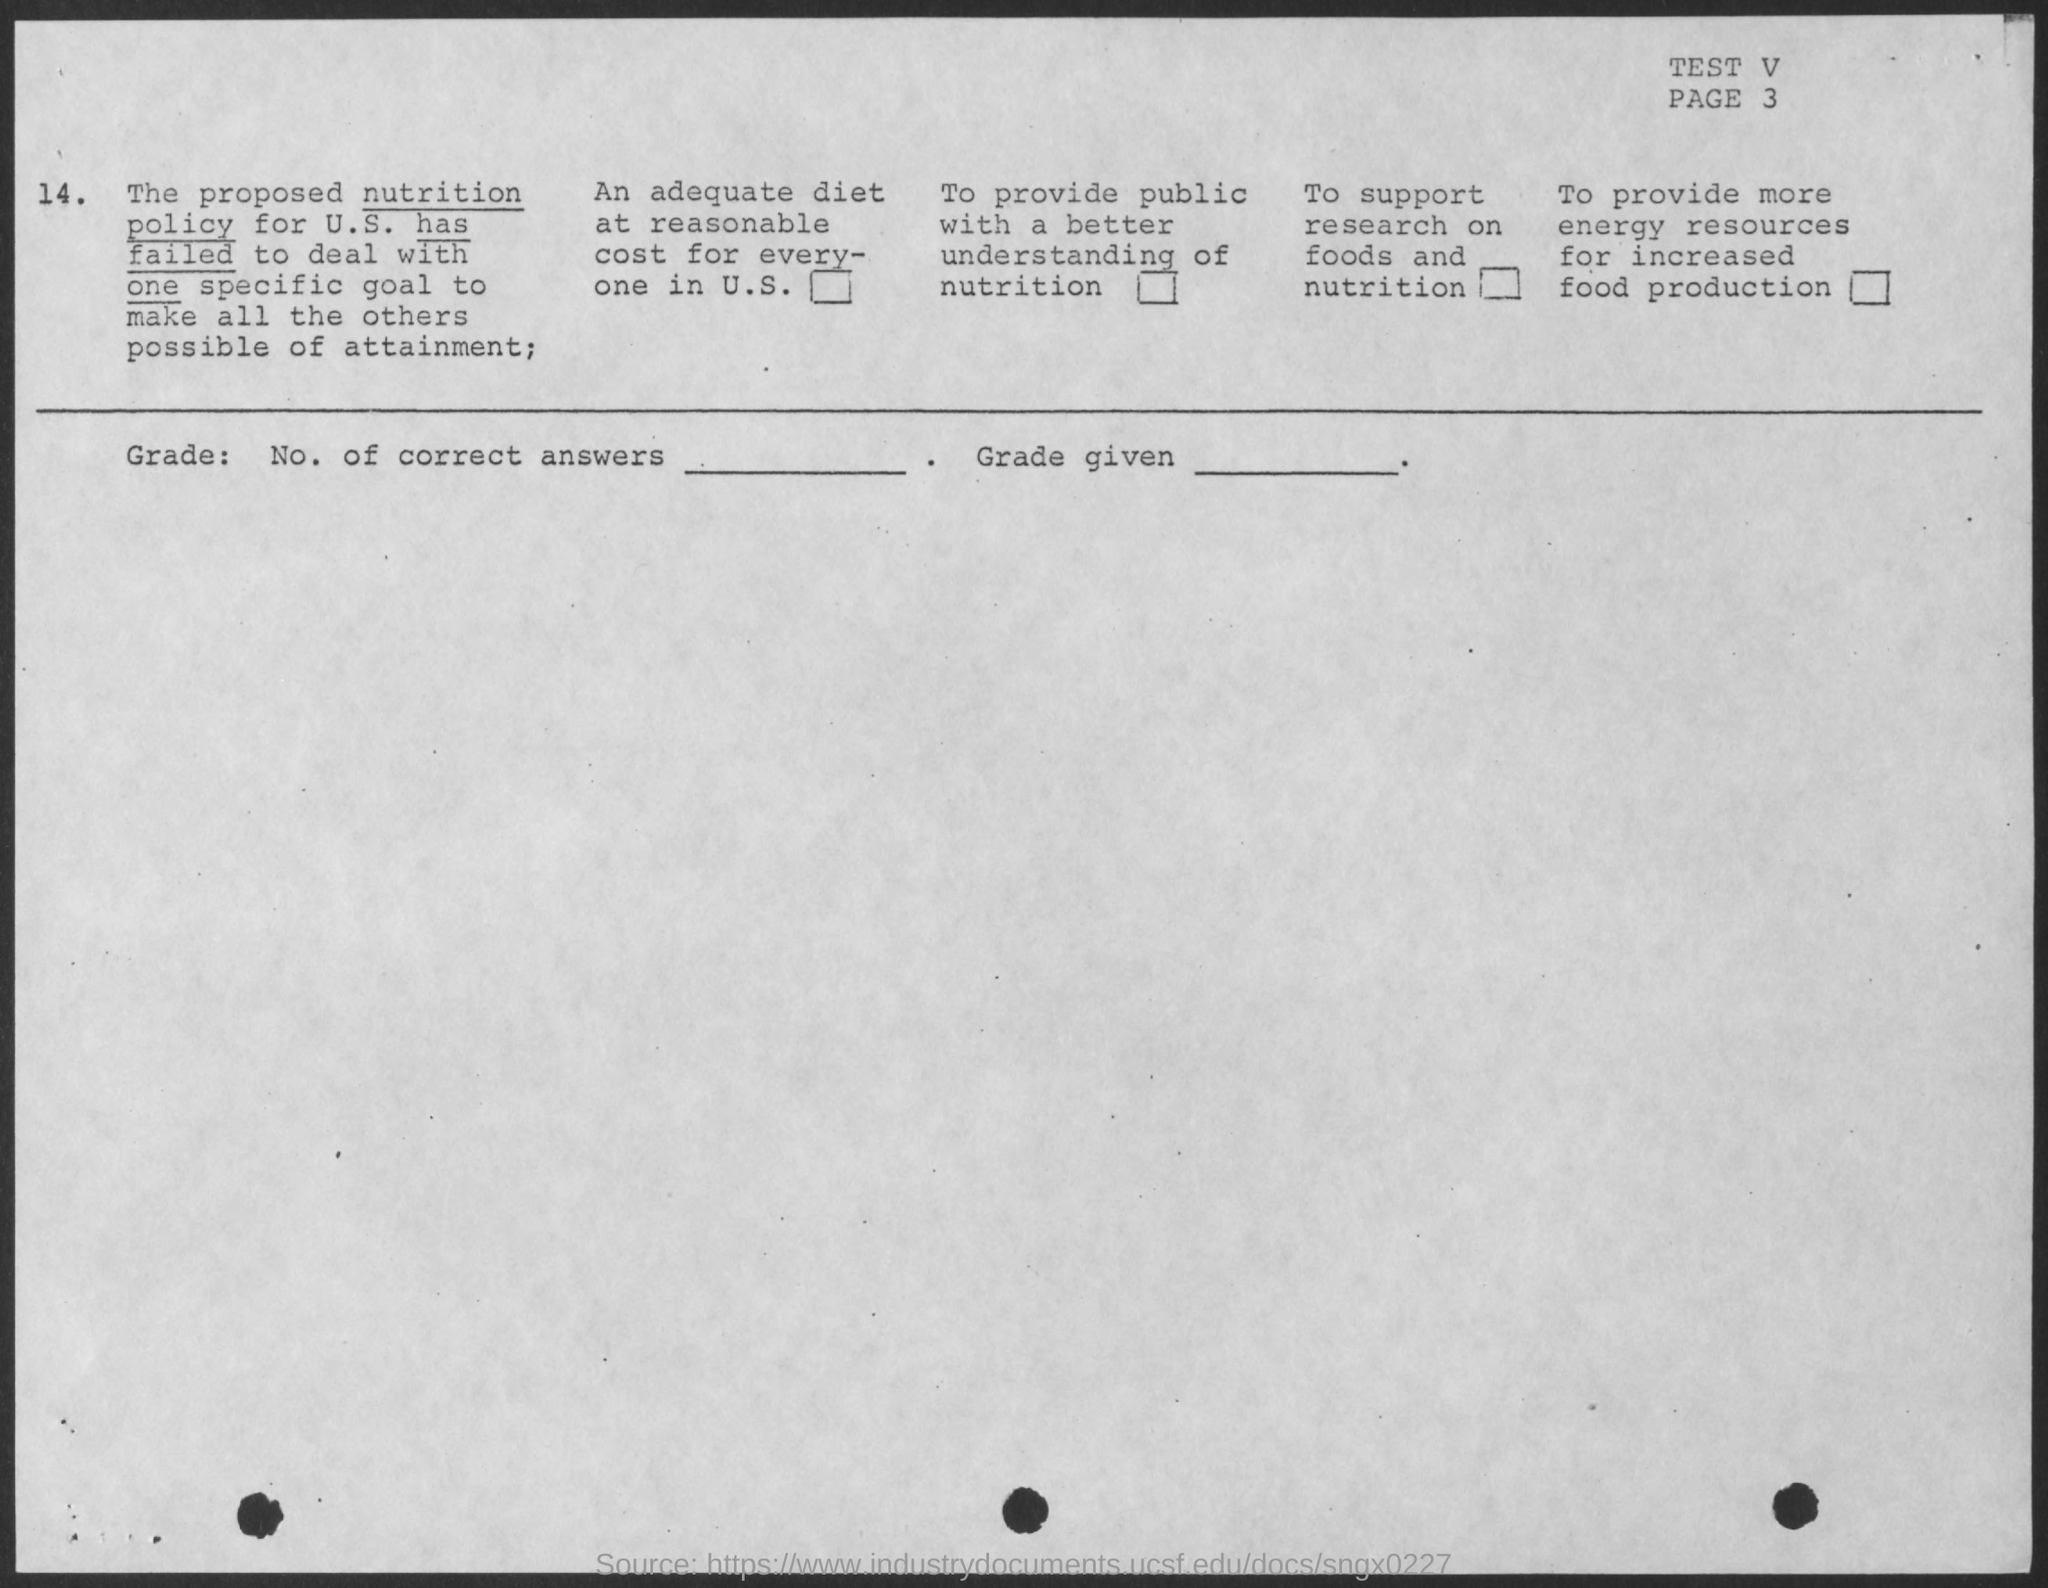What is the test number?
Your response must be concise. V. What is the page number?
Provide a succinct answer. 3. What is the policy mentioned?
Provide a short and direct response. Nutrition policy. The nutrition policy is of which country?
Give a very brief answer. U.S. 